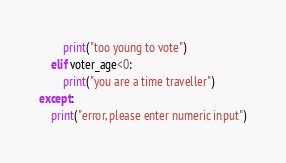<code> <loc_0><loc_0><loc_500><loc_500><_Python_>        print("too young to vote")
    elif voter_age<0:
        print("you are a time traveller")
except:
    print("error, please enter numeric input")
</code> 